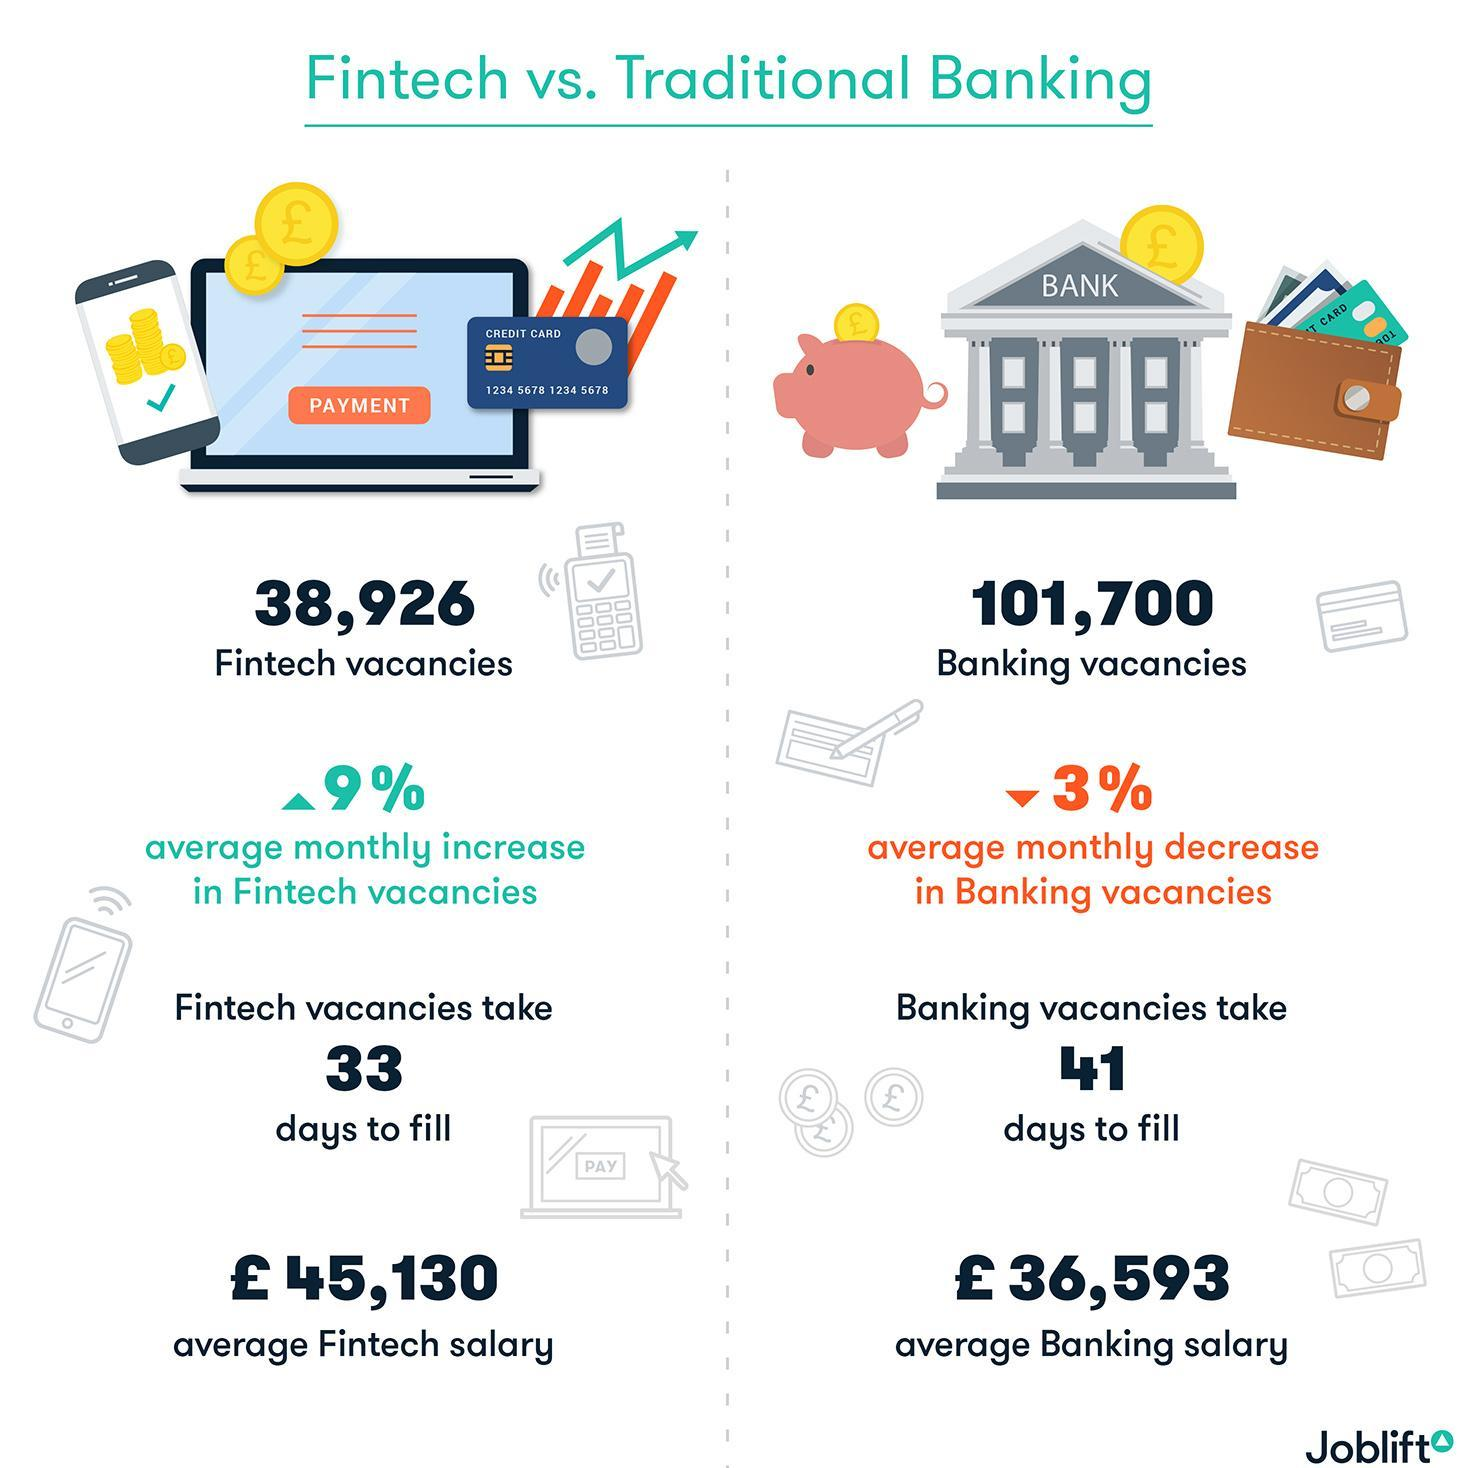What is the total number of vacancies in both traditional banking and Fintech sectors?
Answer the question with a short phrase. 140,626 What is the number of Fintech vacancies? 38,926 Which vacancies fill up faster? Fintech By how much is the fintech average salary higher than the average banking salary ( in pounds)? 8,537 What is the number of banking vacancies? 101,700 What is the average monthly decrease in banking vacancies? 3% What is the average monthly increase in fintech vacancies? 9% How long does it take to fill a banking vacancies? 41 days 